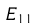Convert formula to latex. <formula><loc_0><loc_0><loc_500><loc_500>E _ { 1 1 }</formula> 